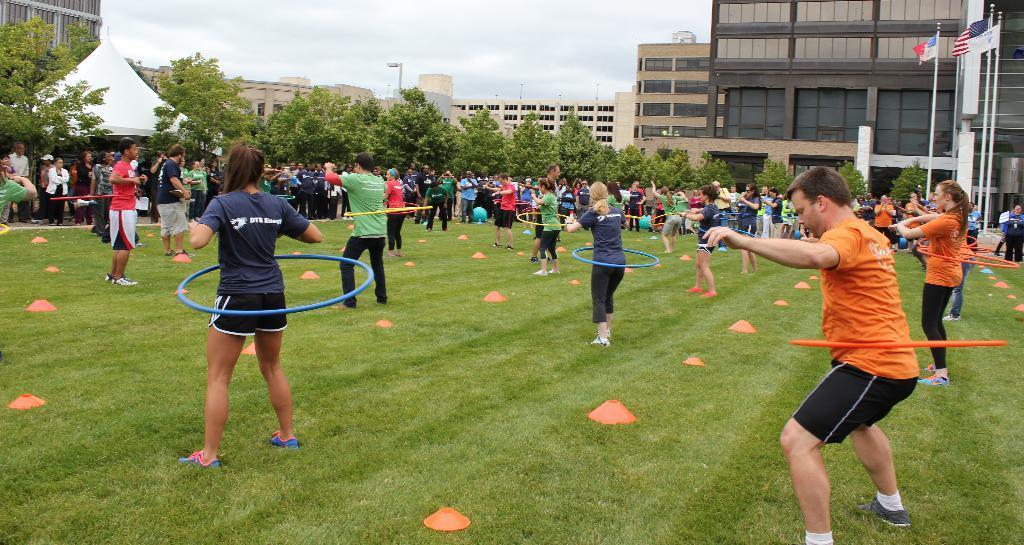Describe this image in one or two sentences. In this image we can see some people and among them few people standing on the ground and it looks like they are performing exercise and we can see some objects on the ground. There are some buildings and trees and there are three flags on the right side of image and we can see the sky. 